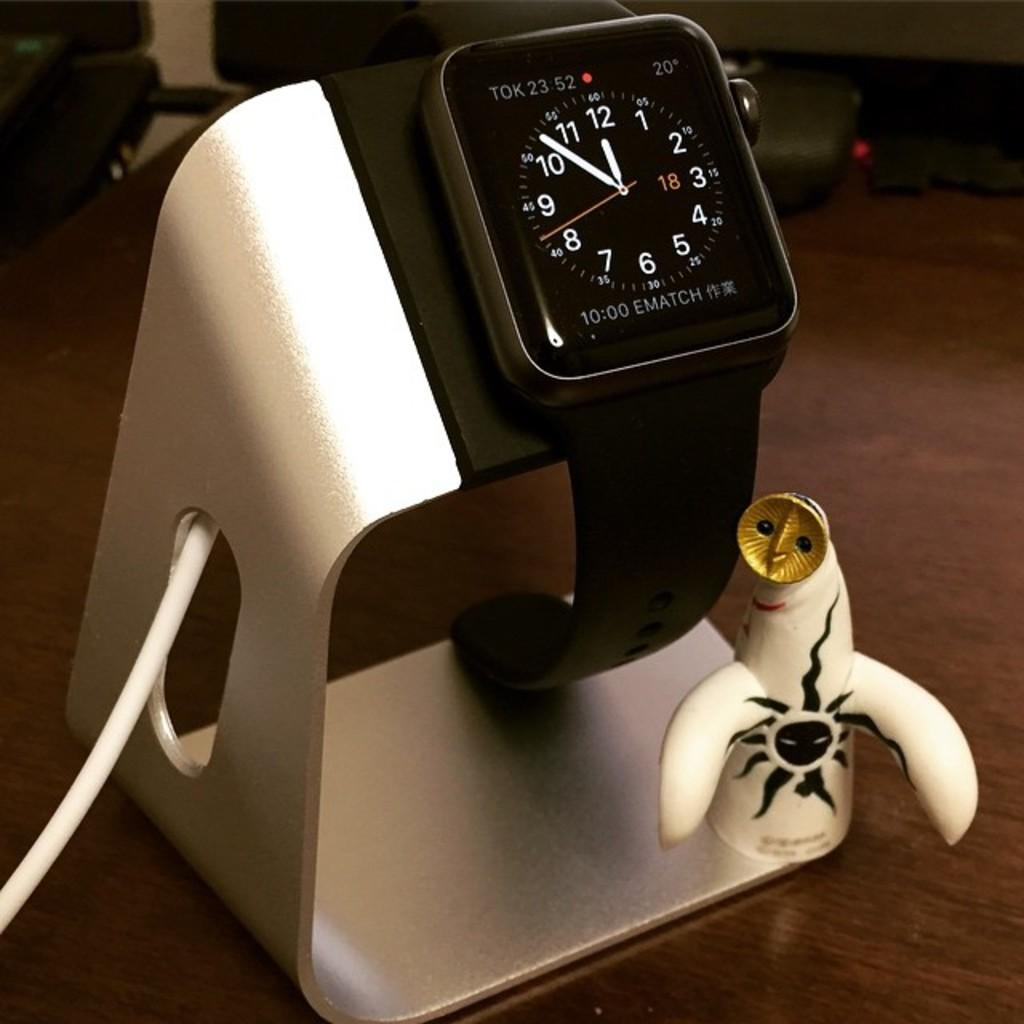<image>
Describe the image concisely. A smart watch reading 11:52 sits on a novelty charging station 